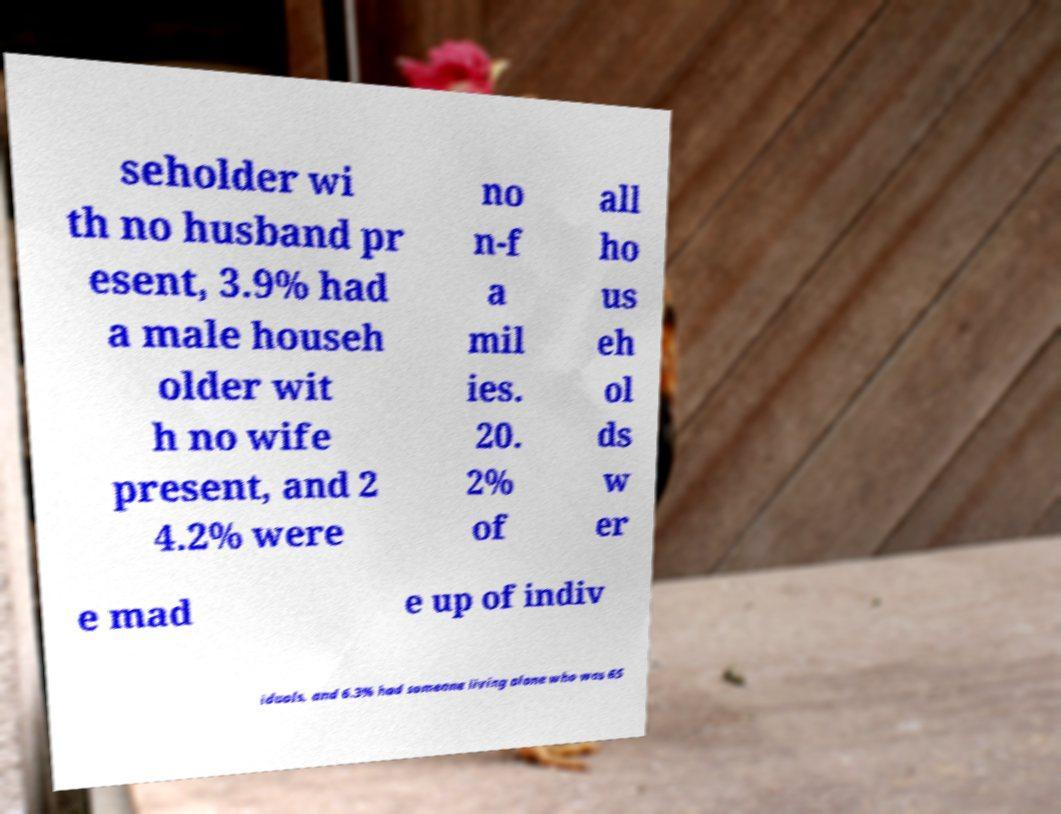I need the written content from this picture converted into text. Can you do that? seholder wi th no husband pr esent, 3.9% had a male househ older wit h no wife present, and 2 4.2% were no n-f a mil ies. 20. 2% of all ho us eh ol ds w er e mad e up of indiv iduals, and 6.3% had someone living alone who was 65 